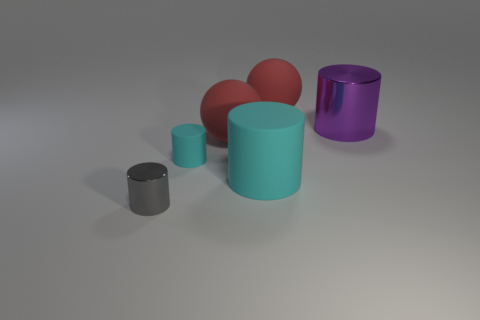Subtract all yellow balls. How many cyan cylinders are left? 2 Subtract all gray cylinders. How many cylinders are left? 3 Subtract all big rubber cylinders. How many cylinders are left? 3 Add 3 big rubber balls. How many objects exist? 9 Subtract all yellow cylinders. Subtract all purple balls. How many cylinders are left? 4 Subtract all cylinders. How many objects are left? 2 Subtract all blue balls. Subtract all matte objects. How many objects are left? 2 Add 6 big red balls. How many big red balls are left? 8 Add 5 large brown matte things. How many large brown matte things exist? 5 Subtract 0 green cylinders. How many objects are left? 6 